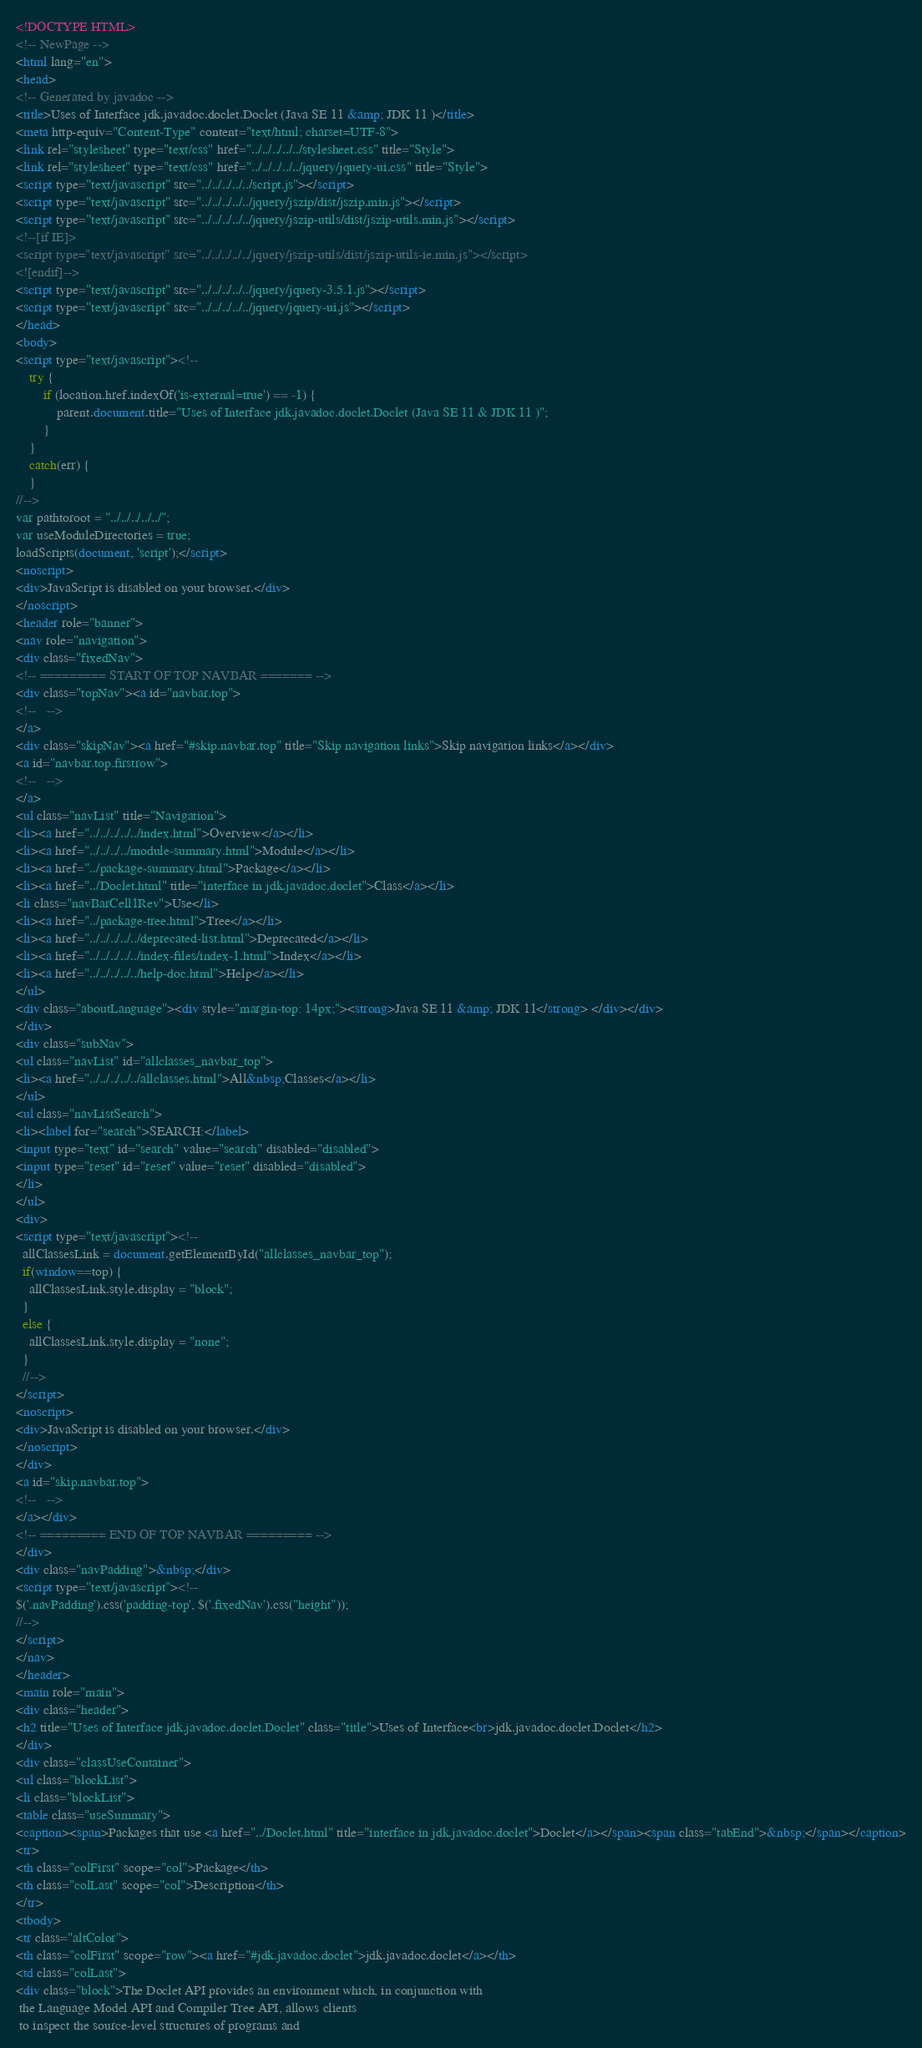<code> <loc_0><loc_0><loc_500><loc_500><_HTML_><!DOCTYPE HTML>
<!-- NewPage -->
<html lang="en">
<head>
<!-- Generated by javadoc -->
<title>Uses of Interface jdk.javadoc.doclet.Doclet (Java SE 11 &amp; JDK 11 )</title>
<meta http-equiv="Content-Type" content="text/html; charset=UTF-8">
<link rel="stylesheet" type="text/css" href="../../../../../stylesheet.css" title="Style">
<link rel="stylesheet" type="text/css" href="../../../../../jquery/jquery-ui.css" title="Style">
<script type="text/javascript" src="../../../../../script.js"></script>
<script type="text/javascript" src="../../../../../jquery/jszip/dist/jszip.min.js"></script>
<script type="text/javascript" src="../../../../../jquery/jszip-utils/dist/jszip-utils.min.js"></script>
<!--[if IE]>
<script type="text/javascript" src="../../../../../jquery/jszip-utils/dist/jszip-utils-ie.min.js"></script>
<![endif]-->
<script type="text/javascript" src="../../../../../jquery/jquery-3.5.1.js"></script>
<script type="text/javascript" src="../../../../../jquery/jquery-ui.js"></script>
</head>
<body>
<script type="text/javascript"><!--
    try {
        if (location.href.indexOf('is-external=true') == -1) {
            parent.document.title="Uses of Interface jdk.javadoc.doclet.Doclet (Java SE 11 & JDK 11 )";
        }
    }
    catch(err) {
    }
//-->
var pathtoroot = "../../../../../";
var useModuleDirectories = true;
loadScripts(document, 'script');</script>
<noscript>
<div>JavaScript is disabled on your browser.</div>
</noscript>
<header role="banner">
<nav role="navigation">
<div class="fixedNav">
<!-- ========= START OF TOP NAVBAR ======= -->
<div class="topNav"><a id="navbar.top">
<!--   -->
</a>
<div class="skipNav"><a href="#skip.navbar.top" title="Skip navigation links">Skip navigation links</a></div>
<a id="navbar.top.firstrow">
<!--   -->
</a>
<ul class="navList" title="Navigation">
<li><a href="../../../../../index.html">Overview</a></li>
<li><a href="../../../../module-summary.html">Module</a></li>
<li><a href="../package-summary.html">Package</a></li>
<li><a href="../Doclet.html" title="interface in jdk.javadoc.doclet">Class</a></li>
<li class="navBarCell1Rev">Use</li>
<li><a href="../package-tree.html">Tree</a></li>
<li><a href="../../../../../deprecated-list.html">Deprecated</a></li>
<li><a href="../../../../../index-files/index-1.html">Index</a></li>
<li><a href="../../../../../help-doc.html">Help</a></li>
</ul>
<div class="aboutLanguage"><div style="margin-top: 14px;"><strong>Java SE 11 &amp; JDK 11</strong> </div></div>
</div>
<div class="subNav">
<ul class="navList" id="allclasses_navbar_top">
<li><a href="../../../../../allclasses.html">All&nbsp;Classes</a></li>
</ul>
<ul class="navListSearch">
<li><label for="search">SEARCH:</label>
<input type="text" id="search" value="search" disabled="disabled">
<input type="reset" id="reset" value="reset" disabled="disabled">
</li>
</ul>
<div>
<script type="text/javascript"><!--
  allClassesLink = document.getElementById("allclasses_navbar_top");
  if(window==top) {
    allClassesLink.style.display = "block";
  }
  else {
    allClassesLink.style.display = "none";
  }
  //-->
</script>
<noscript>
<div>JavaScript is disabled on your browser.</div>
</noscript>
</div>
<a id="skip.navbar.top">
<!--   -->
</a></div>
<!-- ========= END OF TOP NAVBAR ========= -->
</div>
<div class="navPadding">&nbsp;</div>
<script type="text/javascript"><!--
$('.navPadding').css('padding-top', $('.fixedNav').css("height"));
//-->
</script>
</nav>
</header>
<main role="main">
<div class="header">
<h2 title="Uses of Interface jdk.javadoc.doclet.Doclet" class="title">Uses of Interface<br>jdk.javadoc.doclet.Doclet</h2>
</div>
<div class="classUseContainer">
<ul class="blockList">
<li class="blockList">
<table class="useSummary">
<caption><span>Packages that use <a href="../Doclet.html" title="interface in jdk.javadoc.doclet">Doclet</a></span><span class="tabEnd">&nbsp;</span></caption>
<tr>
<th class="colFirst" scope="col">Package</th>
<th class="colLast" scope="col">Description</th>
</tr>
<tbody>
<tr class="altColor">
<th class="colFirst" scope="row"><a href="#jdk.javadoc.doclet">jdk.javadoc.doclet</a></th>
<td class="colLast">
<div class="block">The Doclet API provides an environment which, in conjunction with
 the Language Model API and Compiler Tree API, allows clients
 to inspect the source-level structures of programs and</code> 